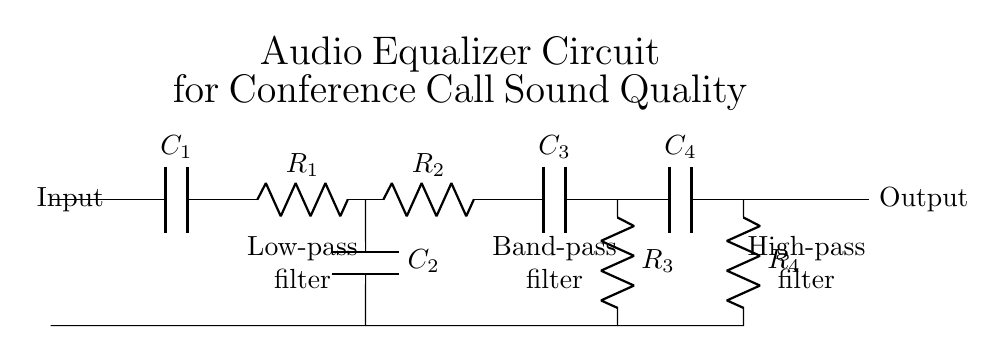What type of circuit is shown? The circuit represented is an audio equalizer circuit, specifically designed to optimize sound quality for conference calls. This is evident from the title provided in the diagram.
Answer: Audio equalizer How many capacitors are in the circuit? The circuit diagram shows four capacitors labeled as C1, C2, C3, and C4. Each component is visually separated and labeled, making it clear how many capacitors are utilized.
Answer: Four What is the function of the component R1? The resistor R1 serves as part of the low-pass filter section of the circuit, which allows low frequencies to pass while attenuating higher frequencies. This is indicated by its labeling in the diagram as part of the low-pass filter.
Answer: Low-pass filter Which filter is positioned between C2 and C3? The band-pass filter is located between C2 and C3. This is deduced from the configuration of the components where R2 connects to C3 immediately following C2.
Answer: Band-pass filter What role does capacitor C4 play in the circuit? Capacitor C4 functions in the high-pass filter section, allowing high frequencies to pass while blocking lower frequencies, as indicated by its position and labeling in the circuit diagram.
Answer: High-pass filter What is the output of the circuit labeled as? The output of the circuit is labeled as "Output," which is shown clearly on the right side of the diagram. This labeling indicates where the processed signal exits the filter circuit.
Answer: Output What does the combination of R2 and R3 represent? The combination of R2 and R3 in this circuit represents the band-pass filter, which selectively allows a certain range of frequencies to pass through while rejecting others. This function is specifically designed into the circuit using these two resistors in conjunction.
Answer: Band-pass filter 